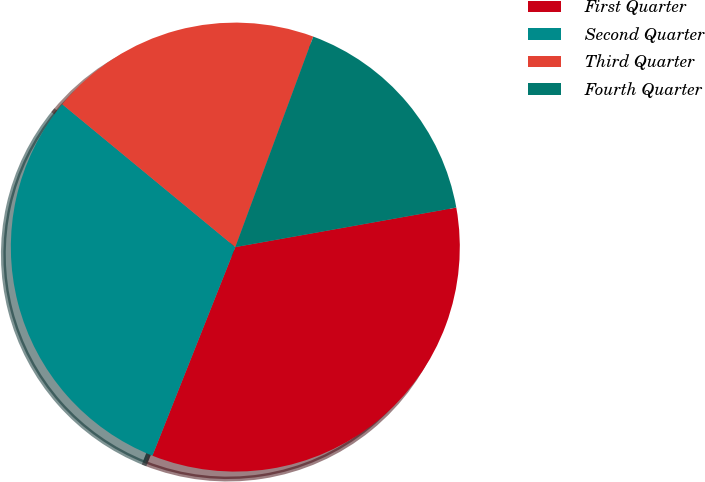Convert chart to OTSL. <chart><loc_0><loc_0><loc_500><loc_500><pie_chart><fcel>First Quarter<fcel>Second Quarter<fcel>Third Quarter<fcel>Fourth Quarter<nl><fcel>33.84%<fcel>29.96%<fcel>19.66%<fcel>16.54%<nl></chart> 